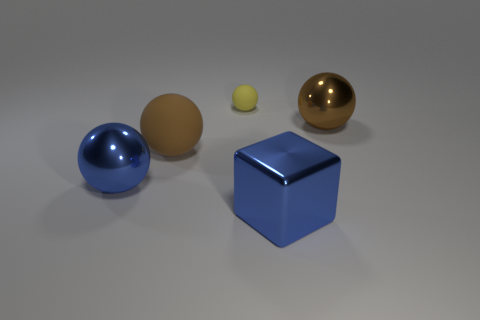What number of rubber things are either large brown balls or large objects?
Ensure brevity in your answer.  1. There is a small yellow thing; what shape is it?
Provide a short and direct response. Sphere. There is a blue block that is the same size as the brown metal sphere; what is its material?
Ensure brevity in your answer.  Metal. How many small objects are green matte cylinders or brown rubber objects?
Your answer should be compact. 0. Are any large gray blocks visible?
Give a very brief answer. No. What is the size of the brown thing that is made of the same material as the yellow sphere?
Make the answer very short. Large. Is the big blue ball made of the same material as the tiny yellow thing?
Offer a terse response. No. What number of other things are there of the same material as the tiny yellow object
Offer a very short reply. 1. What number of big shiny objects are both left of the tiny yellow rubber ball and to the right of the blue ball?
Your response must be concise. 0. What is the color of the tiny rubber sphere?
Your answer should be very brief. Yellow. 